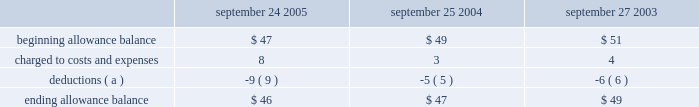Notes to consolidated financial statements ( continued ) note 2 2014financial instruments ( continued ) are not covered by collateral , third-party flooring arrangements , or credit insurance are outstanding with the company 2019s distribution and retail channel partners .
No customer accounted for more than 10% ( 10 % ) of trade receivables as of september 24 , 2005 or september 25 , 2004 .
The table summarizes the activity in the allowance for doubtful accounts ( in millions ) : september 24 , september 25 , september 27 .
( a ) represents amounts written off against the allowance , net of recoveries .
Vendor non-trade receivables the company has non-trade receivables from certain of its manufacturing vendors resulting from the sale of raw material components to these manufacturing vendors who manufacture sub-assemblies or assemble final products for the company .
The company purchases these raw material components directly from suppliers .
These non-trade receivables , which are included in the consolidated balance sheets in other current assets , totaled $ 417 million and $ 276 million as of september 24 , 2005 and september 25 , 2004 , respectively .
The company does not reflect the sale of these components in net sales and does not recognize any profits on these sales until the products are sold through to the end customer at which time the profit is recognized as a reduction of cost of sales .
Derivative financial instruments the company uses derivatives to partially offset its business exposure to foreign exchange and interest rate risk .
Foreign currency forward and option contracts are used to offset the foreign exchange risk on certain existing assets and liabilities and to hedge the foreign exchange risk on expected future cash flows on certain forecasted revenue and cost of sales .
From time to time , the company enters into interest rate derivative agreements to modify the interest rate profile of certain investments and debt .
The company 2019s accounting policies for these instruments are based on whether the instruments are designated as hedge or non-hedge instruments .
The company records all derivatives on the balance sheet at fair value. .
What was the highest ending allowance balance , in millions? 
Computations: table_max(ending allowance balance, none)
Answer: 49.0. 